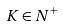<formula> <loc_0><loc_0><loc_500><loc_500>K \in N ^ { + }</formula> 